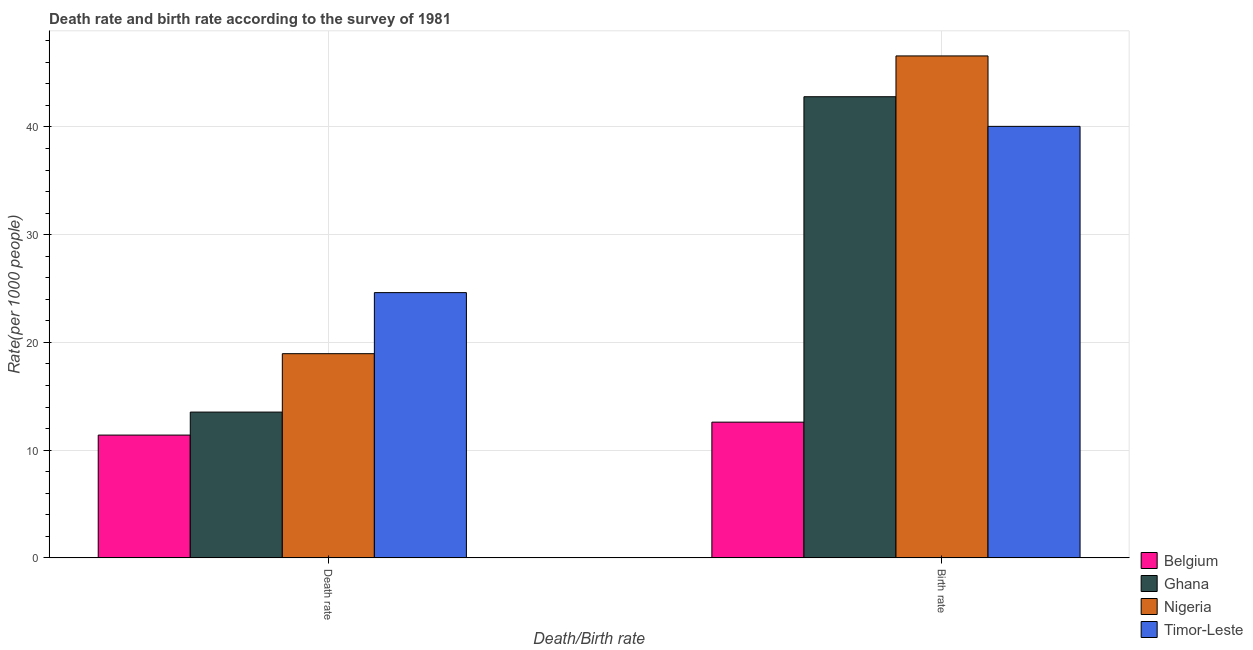How many different coloured bars are there?
Your answer should be very brief. 4. How many groups of bars are there?
Your response must be concise. 2. Are the number of bars on each tick of the X-axis equal?
Offer a terse response. Yes. How many bars are there on the 2nd tick from the left?
Give a very brief answer. 4. What is the label of the 2nd group of bars from the left?
Provide a succinct answer. Birth rate. What is the death rate in Belgium?
Ensure brevity in your answer.  11.4. Across all countries, what is the maximum birth rate?
Keep it short and to the point. 46.59. In which country was the birth rate maximum?
Offer a terse response. Nigeria. In which country was the death rate minimum?
Provide a short and direct response. Belgium. What is the total death rate in the graph?
Make the answer very short. 68.51. What is the difference between the death rate in Belgium and that in Ghana?
Provide a succinct answer. -2.13. What is the difference between the death rate in Nigeria and the birth rate in Timor-Leste?
Offer a terse response. -21.1. What is the average death rate per country?
Offer a very short reply. 17.13. What is the difference between the death rate and birth rate in Ghana?
Give a very brief answer. -29.27. In how many countries, is the birth rate greater than 8 ?
Offer a terse response. 4. What is the ratio of the death rate in Nigeria to that in Belgium?
Offer a terse response. 1.66. What does the 1st bar from the left in Death rate represents?
Provide a short and direct response. Belgium. What does the 1st bar from the right in Death rate represents?
Make the answer very short. Timor-Leste. How many countries are there in the graph?
Ensure brevity in your answer.  4. What is the difference between two consecutive major ticks on the Y-axis?
Keep it short and to the point. 10. Does the graph contain grids?
Your answer should be compact. Yes. Where does the legend appear in the graph?
Offer a very short reply. Bottom right. How are the legend labels stacked?
Provide a short and direct response. Vertical. What is the title of the graph?
Your answer should be very brief. Death rate and birth rate according to the survey of 1981. Does "Korea (Democratic)" appear as one of the legend labels in the graph?
Ensure brevity in your answer.  No. What is the label or title of the X-axis?
Offer a terse response. Death/Birth rate. What is the label or title of the Y-axis?
Offer a terse response. Rate(per 1000 people). What is the Rate(per 1000 people) in Ghana in Death rate?
Your response must be concise. 13.53. What is the Rate(per 1000 people) of Nigeria in Death rate?
Provide a succinct answer. 18.96. What is the Rate(per 1000 people) in Timor-Leste in Death rate?
Provide a short and direct response. 24.62. What is the Rate(per 1000 people) of Ghana in Birth rate?
Offer a terse response. 42.8. What is the Rate(per 1000 people) of Nigeria in Birth rate?
Offer a very short reply. 46.59. What is the Rate(per 1000 people) in Timor-Leste in Birth rate?
Ensure brevity in your answer.  40.05. Across all Death/Birth rate, what is the maximum Rate(per 1000 people) in Belgium?
Make the answer very short. 12.6. Across all Death/Birth rate, what is the maximum Rate(per 1000 people) of Ghana?
Your answer should be compact. 42.8. Across all Death/Birth rate, what is the maximum Rate(per 1000 people) in Nigeria?
Your response must be concise. 46.59. Across all Death/Birth rate, what is the maximum Rate(per 1000 people) in Timor-Leste?
Provide a succinct answer. 40.05. Across all Death/Birth rate, what is the minimum Rate(per 1000 people) in Belgium?
Your answer should be very brief. 11.4. Across all Death/Birth rate, what is the minimum Rate(per 1000 people) in Ghana?
Make the answer very short. 13.53. Across all Death/Birth rate, what is the minimum Rate(per 1000 people) in Nigeria?
Offer a very short reply. 18.96. Across all Death/Birth rate, what is the minimum Rate(per 1000 people) of Timor-Leste?
Your answer should be very brief. 24.62. What is the total Rate(per 1000 people) of Belgium in the graph?
Give a very brief answer. 24. What is the total Rate(per 1000 people) of Ghana in the graph?
Offer a terse response. 56.34. What is the total Rate(per 1000 people) of Nigeria in the graph?
Keep it short and to the point. 65.55. What is the total Rate(per 1000 people) in Timor-Leste in the graph?
Make the answer very short. 64.68. What is the difference between the Rate(per 1000 people) in Ghana in Death rate and that in Birth rate?
Give a very brief answer. -29.27. What is the difference between the Rate(per 1000 people) of Nigeria in Death rate and that in Birth rate?
Provide a short and direct response. -27.64. What is the difference between the Rate(per 1000 people) of Timor-Leste in Death rate and that in Birth rate?
Make the answer very short. -15.43. What is the difference between the Rate(per 1000 people) of Belgium in Death rate and the Rate(per 1000 people) of Ghana in Birth rate?
Ensure brevity in your answer.  -31.41. What is the difference between the Rate(per 1000 people) in Belgium in Death rate and the Rate(per 1000 people) in Nigeria in Birth rate?
Provide a succinct answer. -35.19. What is the difference between the Rate(per 1000 people) of Belgium in Death rate and the Rate(per 1000 people) of Timor-Leste in Birth rate?
Offer a terse response. -28.65. What is the difference between the Rate(per 1000 people) of Ghana in Death rate and the Rate(per 1000 people) of Nigeria in Birth rate?
Provide a short and direct response. -33.06. What is the difference between the Rate(per 1000 people) of Ghana in Death rate and the Rate(per 1000 people) of Timor-Leste in Birth rate?
Your answer should be very brief. -26.52. What is the difference between the Rate(per 1000 people) of Nigeria in Death rate and the Rate(per 1000 people) of Timor-Leste in Birth rate?
Provide a succinct answer. -21.1. What is the average Rate(per 1000 people) of Belgium per Death/Birth rate?
Your answer should be very brief. 12. What is the average Rate(per 1000 people) of Ghana per Death/Birth rate?
Ensure brevity in your answer.  28.17. What is the average Rate(per 1000 people) in Nigeria per Death/Birth rate?
Offer a terse response. 32.77. What is the average Rate(per 1000 people) in Timor-Leste per Death/Birth rate?
Offer a terse response. 32.34. What is the difference between the Rate(per 1000 people) of Belgium and Rate(per 1000 people) of Ghana in Death rate?
Provide a short and direct response. -2.13. What is the difference between the Rate(per 1000 people) in Belgium and Rate(per 1000 people) in Nigeria in Death rate?
Give a very brief answer. -7.56. What is the difference between the Rate(per 1000 people) of Belgium and Rate(per 1000 people) of Timor-Leste in Death rate?
Make the answer very short. -13.22. What is the difference between the Rate(per 1000 people) in Ghana and Rate(per 1000 people) in Nigeria in Death rate?
Make the answer very short. -5.42. What is the difference between the Rate(per 1000 people) in Ghana and Rate(per 1000 people) in Timor-Leste in Death rate?
Your answer should be very brief. -11.09. What is the difference between the Rate(per 1000 people) in Nigeria and Rate(per 1000 people) in Timor-Leste in Death rate?
Make the answer very short. -5.67. What is the difference between the Rate(per 1000 people) of Belgium and Rate(per 1000 people) of Ghana in Birth rate?
Offer a terse response. -30.2. What is the difference between the Rate(per 1000 people) in Belgium and Rate(per 1000 people) in Nigeria in Birth rate?
Offer a very short reply. -33.99. What is the difference between the Rate(per 1000 people) in Belgium and Rate(per 1000 people) in Timor-Leste in Birth rate?
Your response must be concise. -27.45. What is the difference between the Rate(per 1000 people) in Ghana and Rate(per 1000 people) in Nigeria in Birth rate?
Your answer should be very brief. -3.79. What is the difference between the Rate(per 1000 people) in Ghana and Rate(per 1000 people) in Timor-Leste in Birth rate?
Offer a very short reply. 2.75. What is the difference between the Rate(per 1000 people) in Nigeria and Rate(per 1000 people) in Timor-Leste in Birth rate?
Your answer should be compact. 6.54. What is the ratio of the Rate(per 1000 people) of Belgium in Death rate to that in Birth rate?
Keep it short and to the point. 0.9. What is the ratio of the Rate(per 1000 people) in Ghana in Death rate to that in Birth rate?
Ensure brevity in your answer.  0.32. What is the ratio of the Rate(per 1000 people) in Nigeria in Death rate to that in Birth rate?
Provide a short and direct response. 0.41. What is the ratio of the Rate(per 1000 people) in Timor-Leste in Death rate to that in Birth rate?
Provide a succinct answer. 0.61. What is the difference between the highest and the second highest Rate(per 1000 people) in Belgium?
Your response must be concise. 1.2. What is the difference between the highest and the second highest Rate(per 1000 people) of Ghana?
Offer a terse response. 29.27. What is the difference between the highest and the second highest Rate(per 1000 people) in Nigeria?
Provide a short and direct response. 27.64. What is the difference between the highest and the second highest Rate(per 1000 people) in Timor-Leste?
Keep it short and to the point. 15.43. What is the difference between the highest and the lowest Rate(per 1000 people) of Ghana?
Provide a succinct answer. 29.27. What is the difference between the highest and the lowest Rate(per 1000 people) in Nigeria?
Your answer should be compact. 27.64. What is the difference between the highest and the lowest Rate(per 1000 people) of Timor-Leste?
Give a very brief answer. 15.43. 